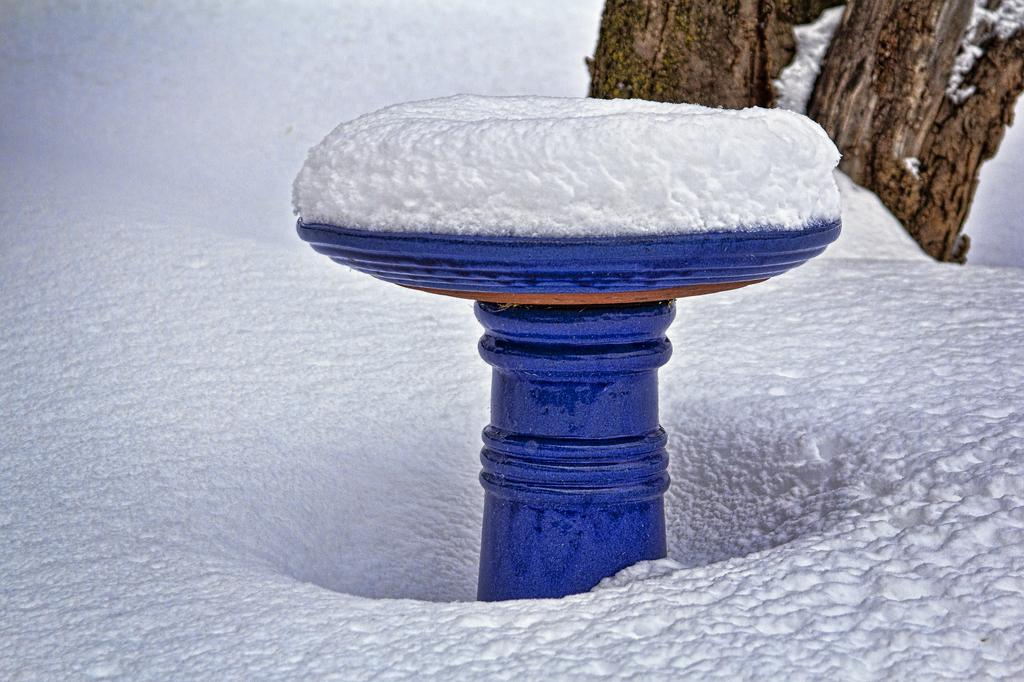What type of natural feature can be seen in the background of the image? Tree trunks are visible in the background of the image. What color is the prominent object in the image? There is a blue object in the image. What is covering the blue object? Snow is present on the blue object. Where is snow visible in the image? Snow is visible at the bottom portion of the image. How does the regret manifest itself in the image? There is no indication of regret in the image; it is not a subject or emotion depicted. 